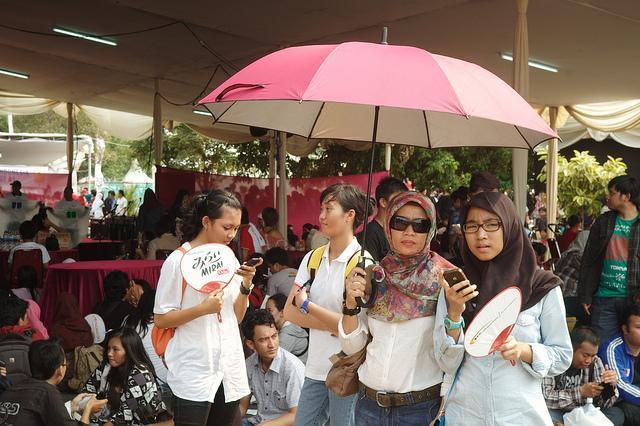How many people are there?
Give a very brief answer. 10. How many laptops are there?
Give a very brief answer. 0. 